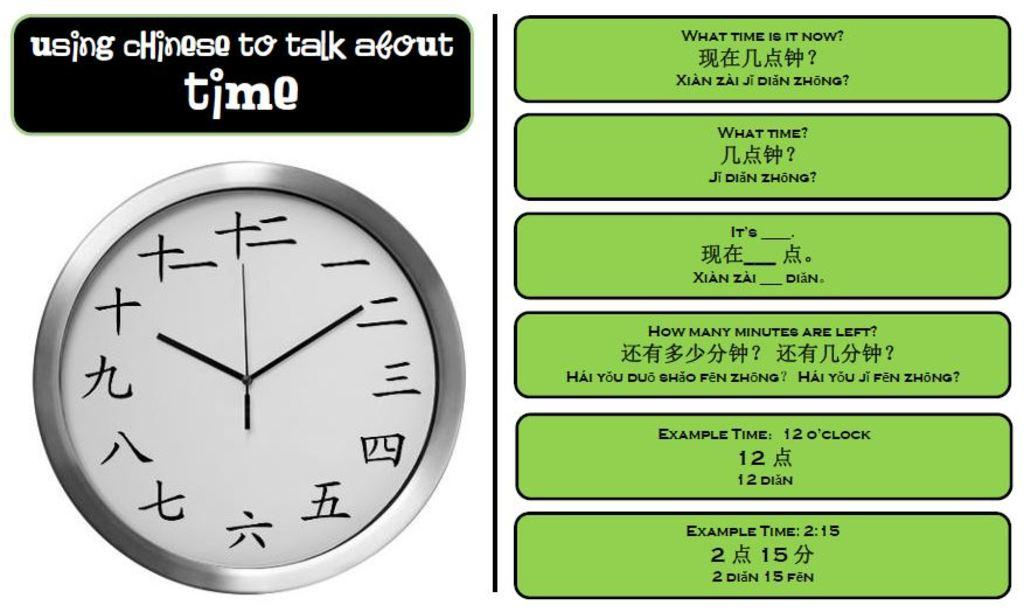<image>
Share a concise interpretation of the image provided. A clock showing Chinese letters says Using Chinese to talk about time above it. 